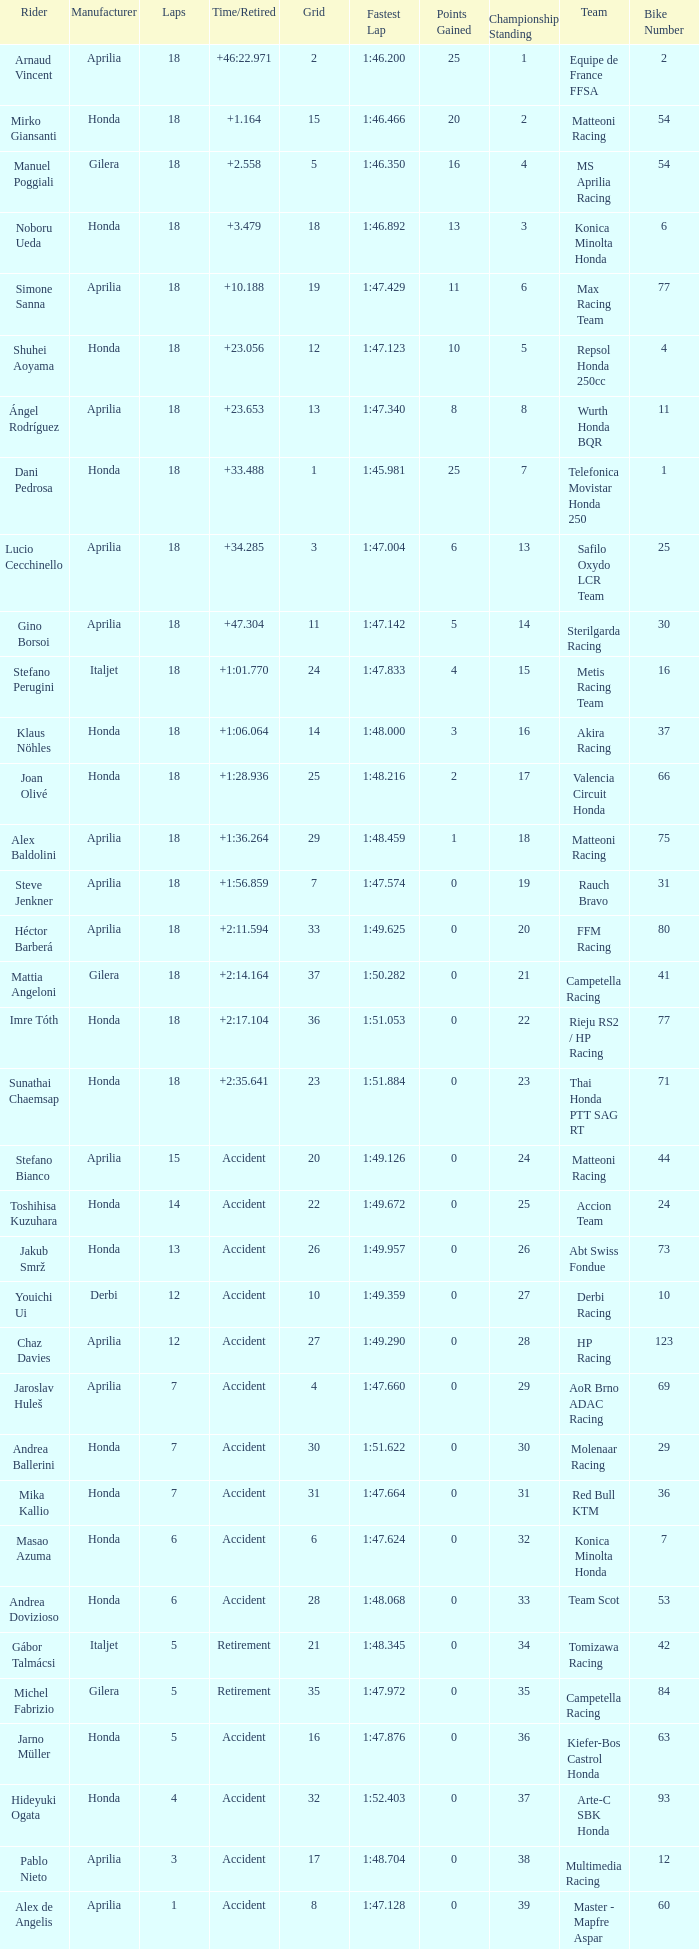What is the time/retired of the honda manufacturer with a grid less than 26, 18 laps, and joan olivé as the rider? +1:28.936. 